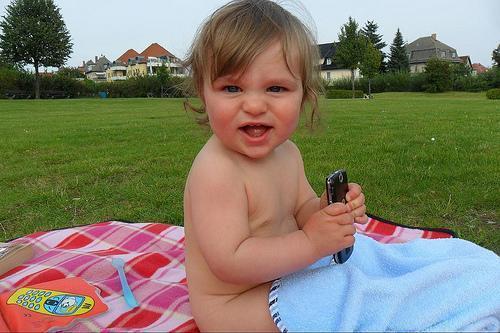How many blankets are in this picture?
Give a very brief answer. 2. How many people are in this picture?
Give a very brief answer. 1. 